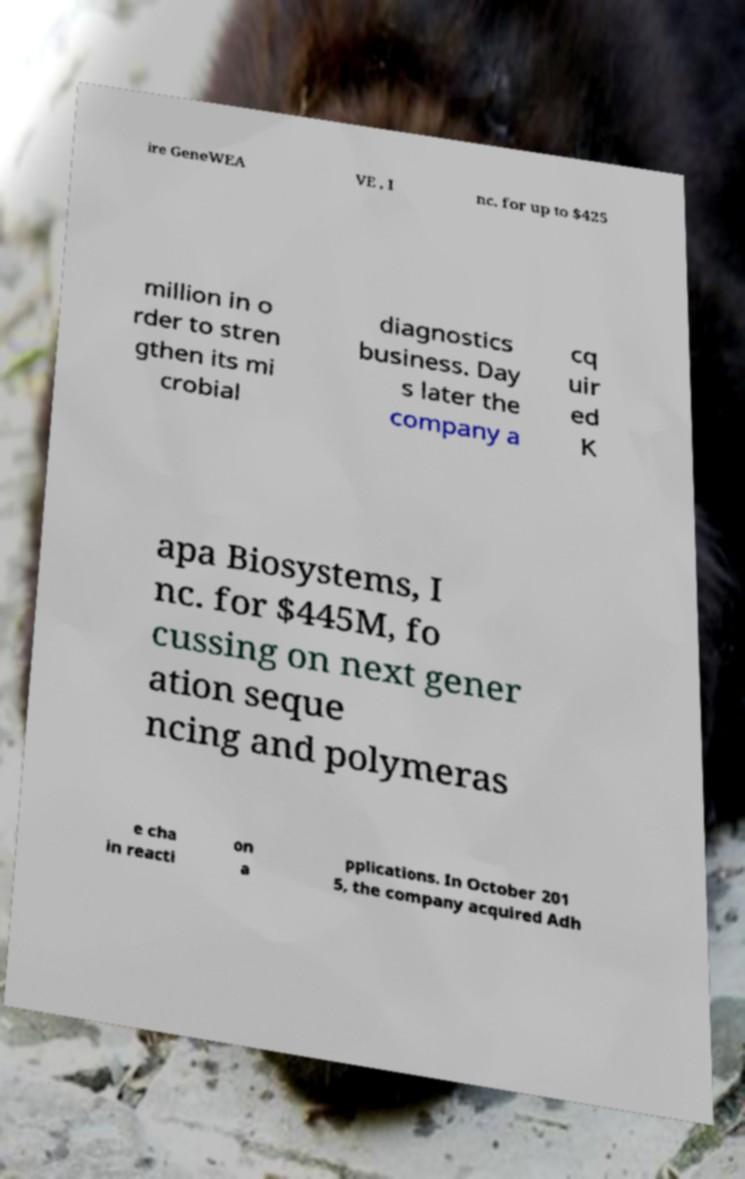Could you assist in decoding the text presented in this image and type it out clearly? ire GeneWEA VE , I nc. for up to $425 million in o rder to stren gthen its mi crobial diagnostics business. Day s later the company a cq uir ed K apa Biosystems, I nc. for $445M, fo cussing on next gener ation seque ncing and polymeras e cha in reacti on a pplications. In October 201 5, the company acquired Adh 